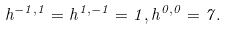<formula> <loc_0><loc_0><loc_500><loc_500>h ^ { - 1 , 1 } = h ^ { 1 , - 1 } = 1 , h ^ { 0 , 0 } = 7 .</formula> 